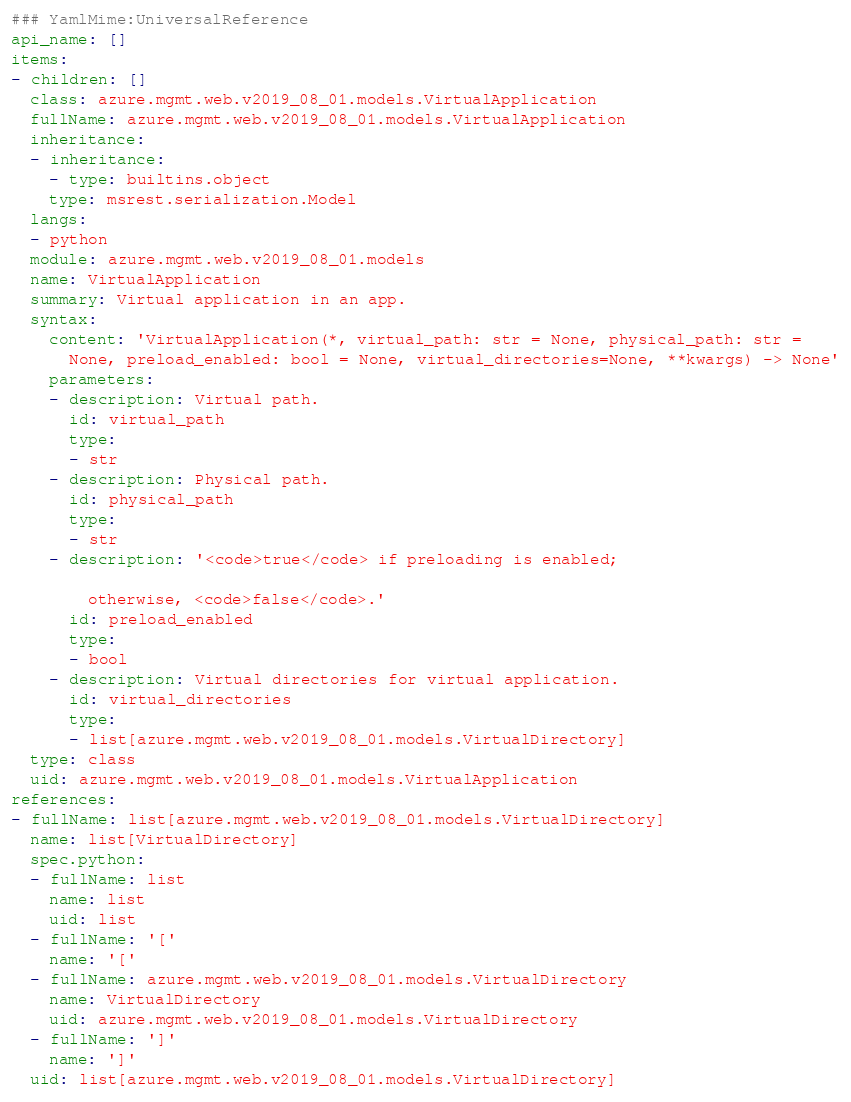<code> <loc_0><loc_0><loc_500><loc_500><_YAML_>### YamlMime:UniversalReference
api_name: []
items:
- children: []
  class: azure.mgmt.web.v2019_08_01.models.VirtualApplication
  fullName: azure.mgmt.web.v2019_08_01.models.VirtualApplication
  inheritance:
  - inheritance:
    - type: builtins.object
    type: msrest.serialization.Model
  langs:
  - python
  module: azure.mgmt.web.v2019_08_01.models
  name: VirtualApplication
  summary: Virtual application in an app.
  syntax:
    content: 'VirtualApplication(*, virtual_path: str = None, physical_path: str =
      None, preload_enabled: bool = None, virtual_directories=None, **kwargs) -> None'
    parameters:
    - description: Virtual path.
      id: virtual_path
      type:
      - str
    - description: Physical path.
      id: physical_path
      type:
      - str
    - description: '<code>true</code> if preloading is enabled;

        otherwise, <code>false</code>.'
      id: preload_enabled
      type:
      - bool
    - description: Virtual directories for virtual application.
      id: virtual_directories
      type:
      - list[azure.mgmt.web.v2019_08_01.models.VirtualDirectory]
  type: class
  uid: azure.mgmt.web.v2019_08_01.models.VirtualApplication
references:
- fullName: list[azure.mgmt.web.v2019_08_01.models.VirtualDirectory]
  name: list[VirtualDirectory]
  spec.python:
  - fullName: list
    name: list
    uid: list
  - fullName: '['
    name: '['
  - fullName: azure.mgmt.web.v2019_08_01.models.VirtualDirectory
    name: VirtualDirectory
    uid: azure.mgmt.web.v2019_08_01.models.VirtualDirectory
  - fullName: ']'
    name: ']'
  uid: list[azure.mgmt.web.v2019_08_01.models.VirtualDirectory]
</code> 